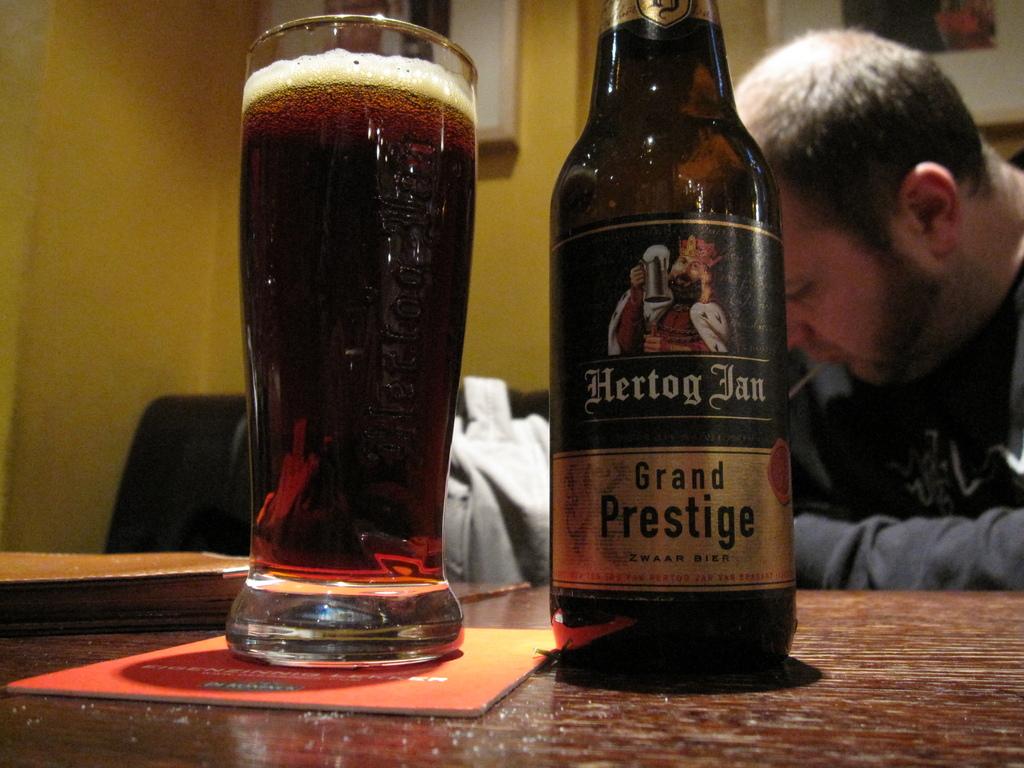What kind of beer is he drinking?
Make the answer very short. Grand prestige. Who is the creator of the beer?
Your response must be concise. Hertog jan. 